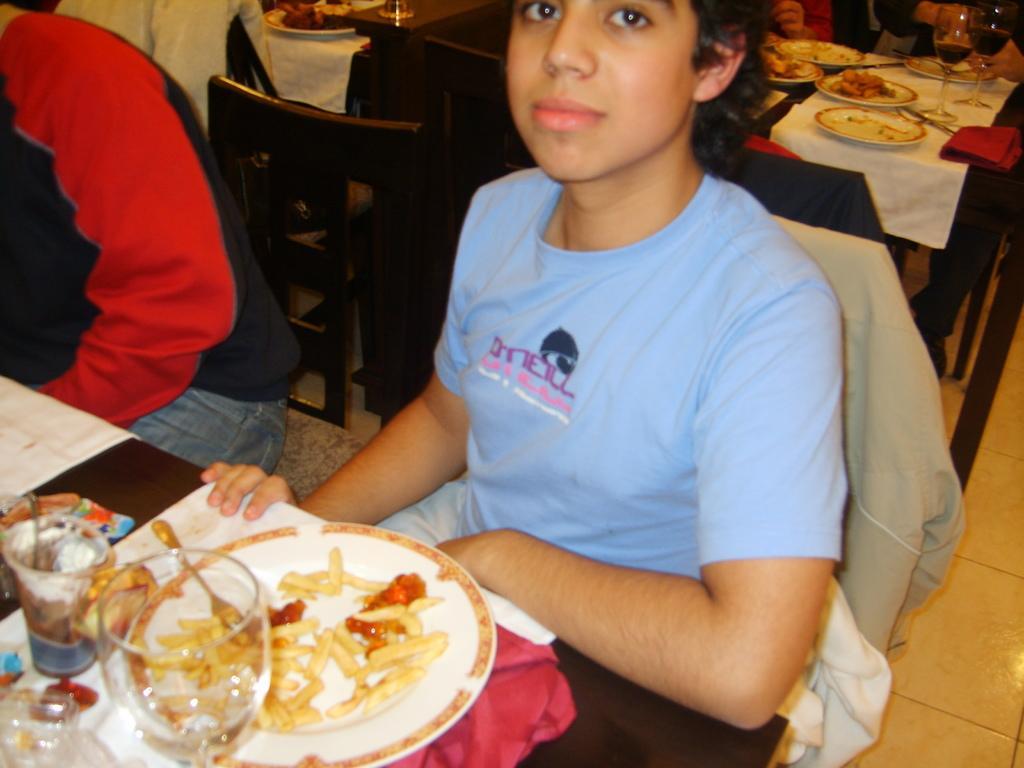Please provide a concise description of this image. In this image there is a woman sitting in chair , and in table there are glass, french fries, sauce , plate in table and group of persons sitting in chair , there is table. 